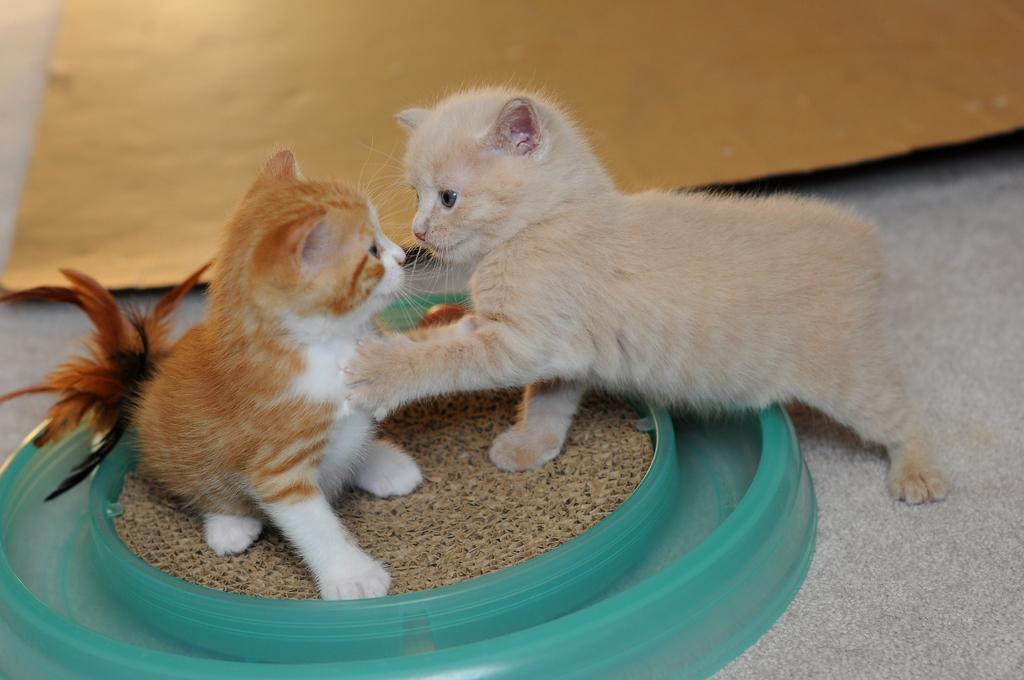How many cats are in the image? There are two cats in the image. What are the cats doing in the image? The cats are on an object. What is the object on which the cats are sitting? The object is on a surface. What is on the floor in the image? There is a sheet on the floor in the image. What type of shoe is being used in the battle depicted in the image? There is no battle or shoe present in the image; it features two cats on an object. 